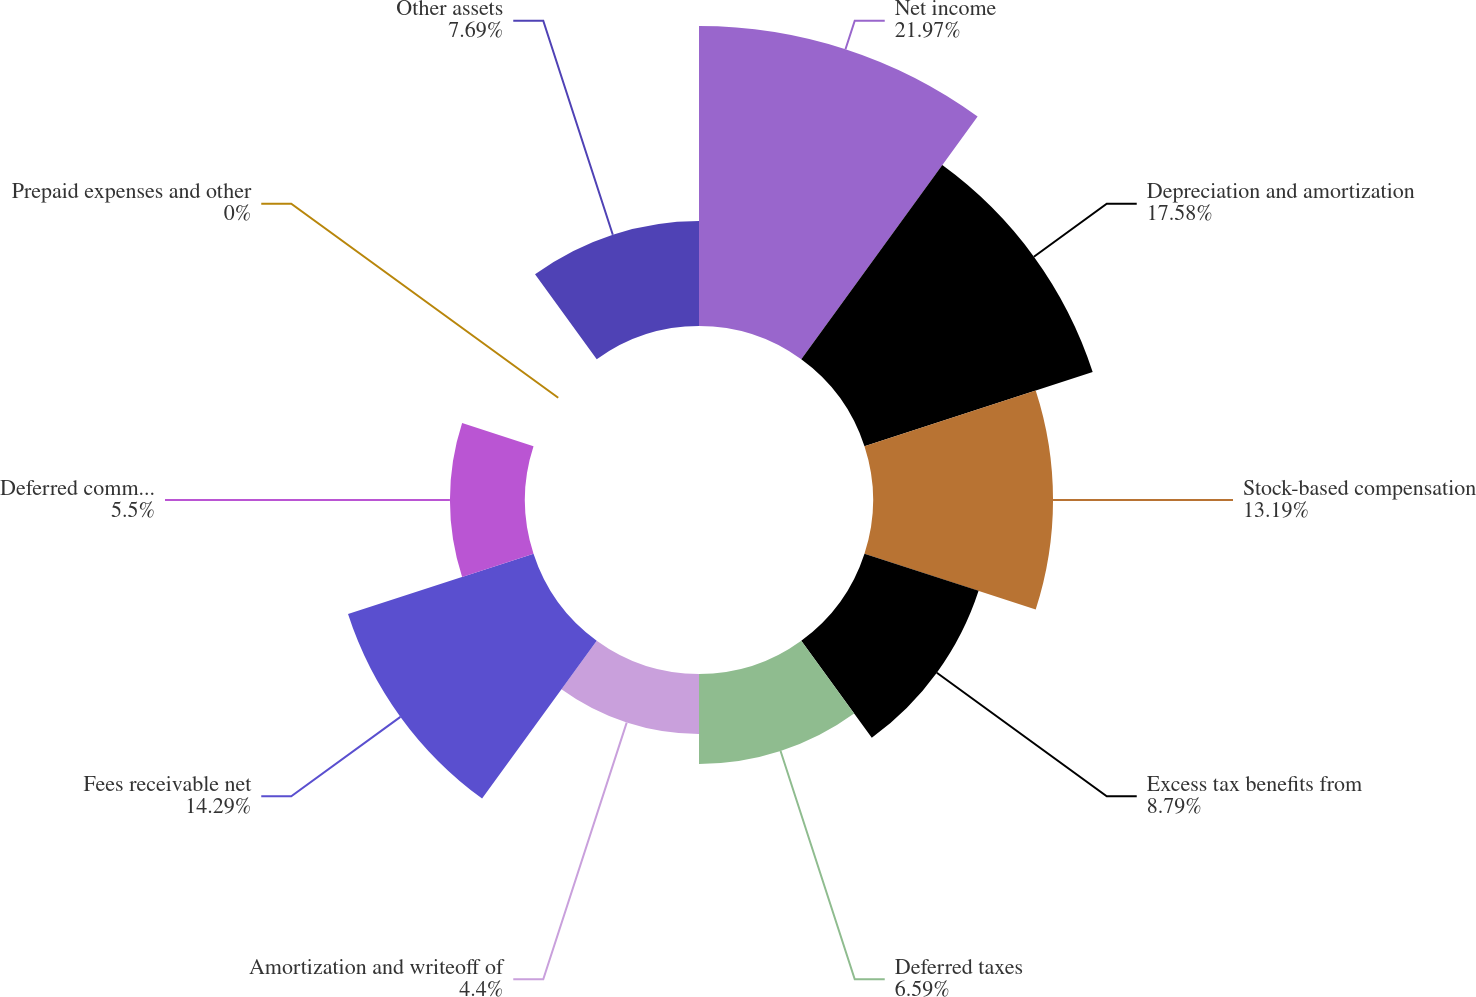Convert chart to OTSL. <chart><loc_0><loc_0><loc_500><loc_500><pie_chart><fcel>Net income<fcel>Depreciation and amortization<fcel>Stock-based compensation<fcel>Excess tax benefits from<fcel>Deferred taxes<fcel>Amortization and writeoff of<fcel>Fees receivable net<fcel>Deferred commissions<fcel>Prepaid expenses and other<fcel>Other assets<nl><fcel>21.98%<fcel>17.58%<fcel>13.19%<fcel>8.79%<fcel>6.59%<fcel>4.4%<fcel>14.29%<fcel>5.5%<fcel>0.0%<fcel>7.69%<nl></chart> 